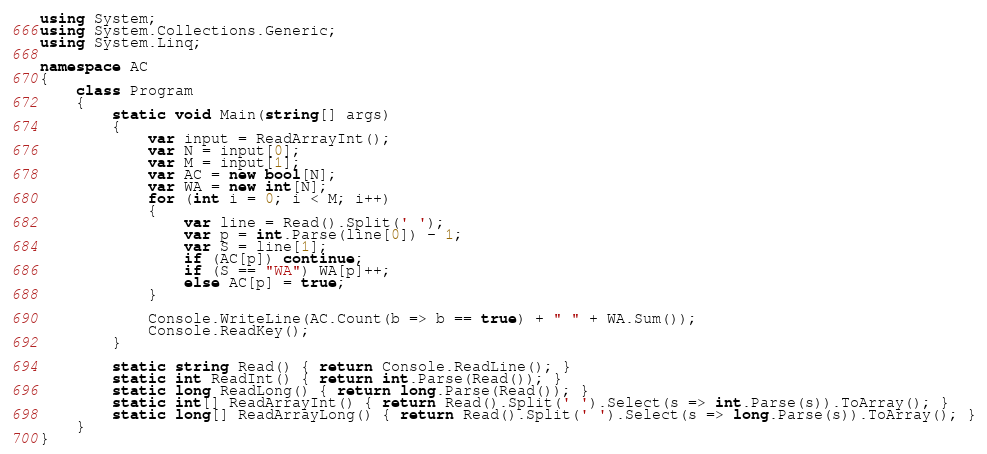<code> <loc_0><loc_0><loc_500><loc_500><_C#_>using System;
using System.Collections.Generic;
using System.Linq;

namespace AC
{
    class Program
    {
        static void Main(string[] args)
        {
            var input = ReadArrayInt();
            var N = input[0];
            var M = input[1];
            var AC = new bool[N];
            var WA = new int[N];
            for (int i = 0; i < M; i++)
            {
                var line = Read().Split(' ');
                var p = int.Parse(line[0]) - 1;
                var S = line[1];
                if (AC[p]) continue;
                if (S == "WA") WA[p]++;
                else AC[p] = true;
            }

            Console.WriteLine(AC.Count(b => b == true) + " " + WA.Sum());
            Console.ReadKey();
        }

        static string Read() { return Console.ReadLine(); }
        static int ReadInt() { return int.Parse(Read()); }
        static long ReadLong() { return long.Parse(Read()); }
        static int[] ReadArrayInt() { return Read().Split(' ').Select(s => int.Parse(s)).ToArray(); }
        static long[] ReadArrayLong() { return Read().Split(' ').Select(s => long.Parse(s)).ToArray(); }
    }
}</code> 